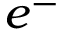<formula> <loc_0><loc_0><loc_500><loc_500>e ^ { - }</formula> 